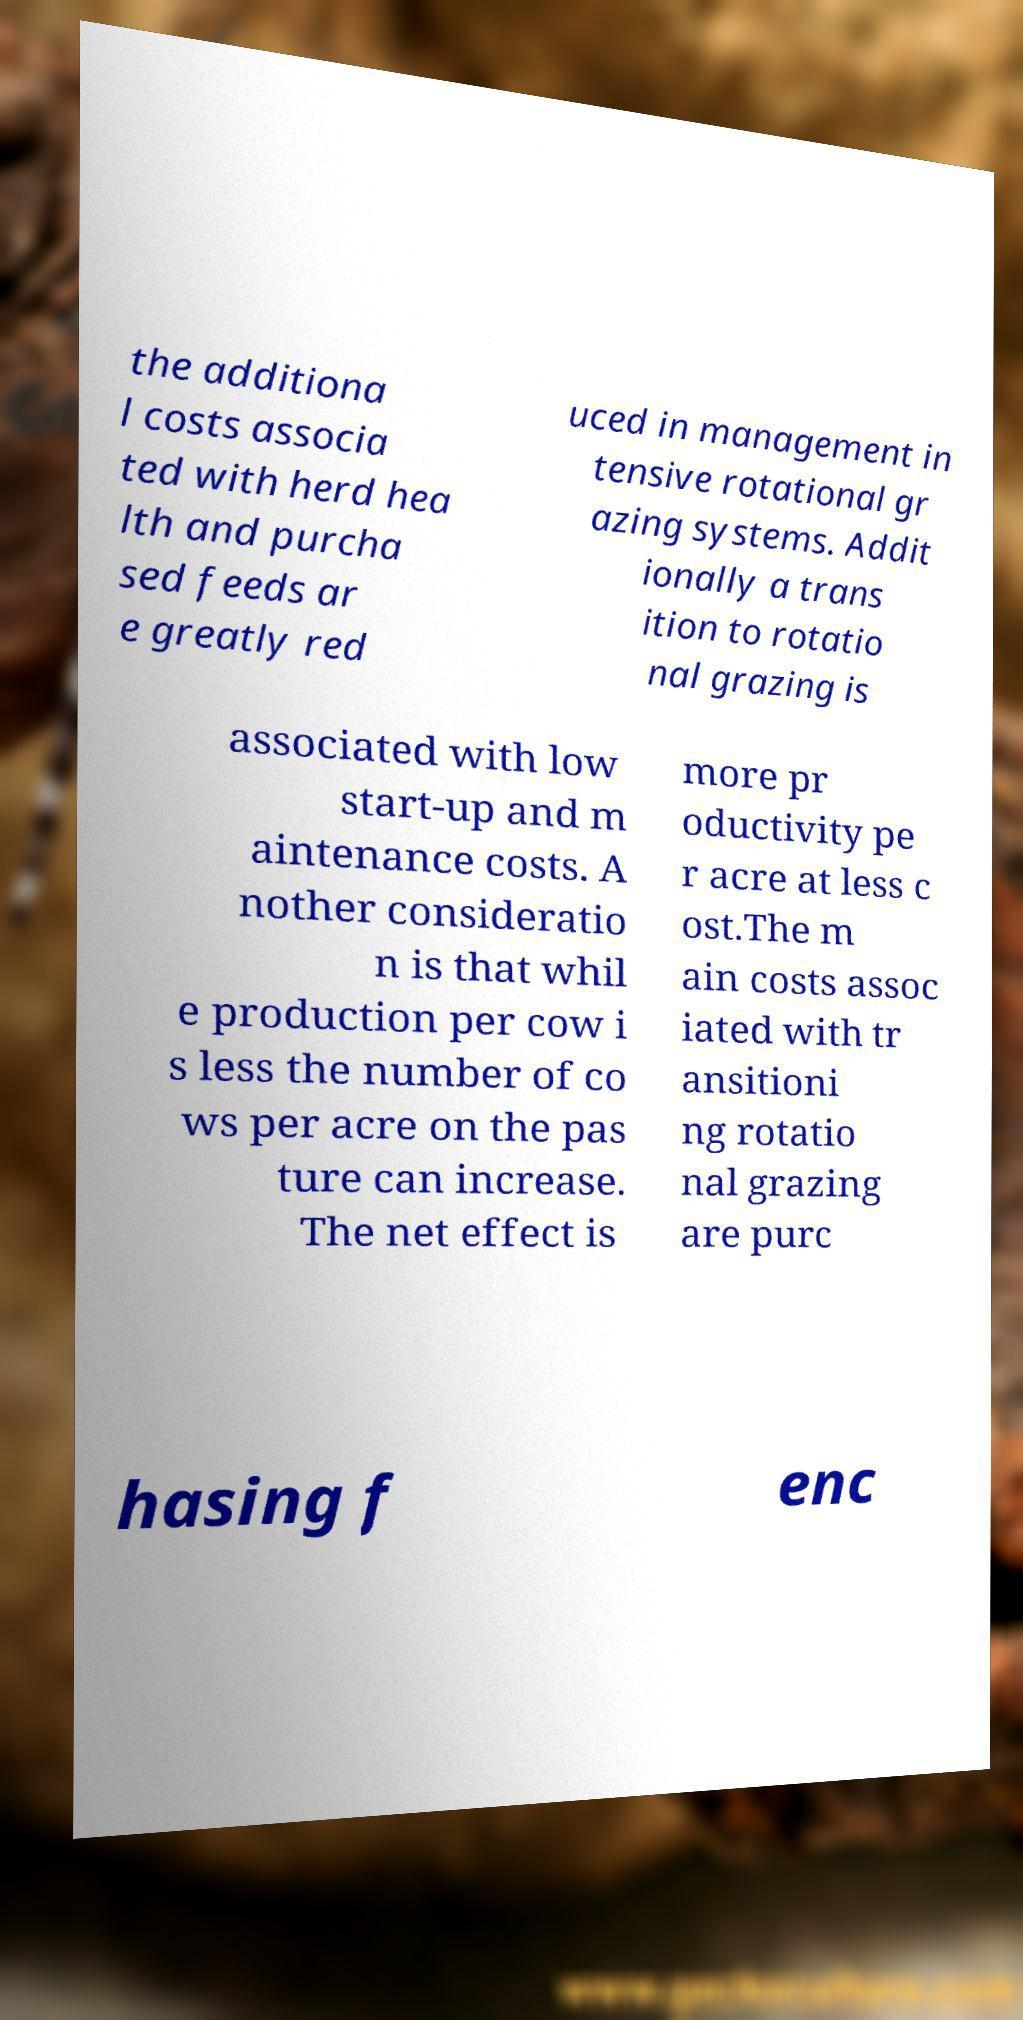Please identify and transcribe the text found in this image. the additiona l costs associa ted with herd hea lth and purcha sed feeds ar e greatly red uced in management in tensive rotational gr azing systems. Addit ionally a trans ition to rotatio nal grazing is associated with low start-up and m aintenance costs. A nother consideratio n is that whil e production per cow i s less the number of co ws per acre on the pas ture can increase. The net effect is more pr oductivity pe r acre at less c ost.The m ain costs assoc iated with tr ansitioni ng rotatio nal grazing are purc hasing f enc 